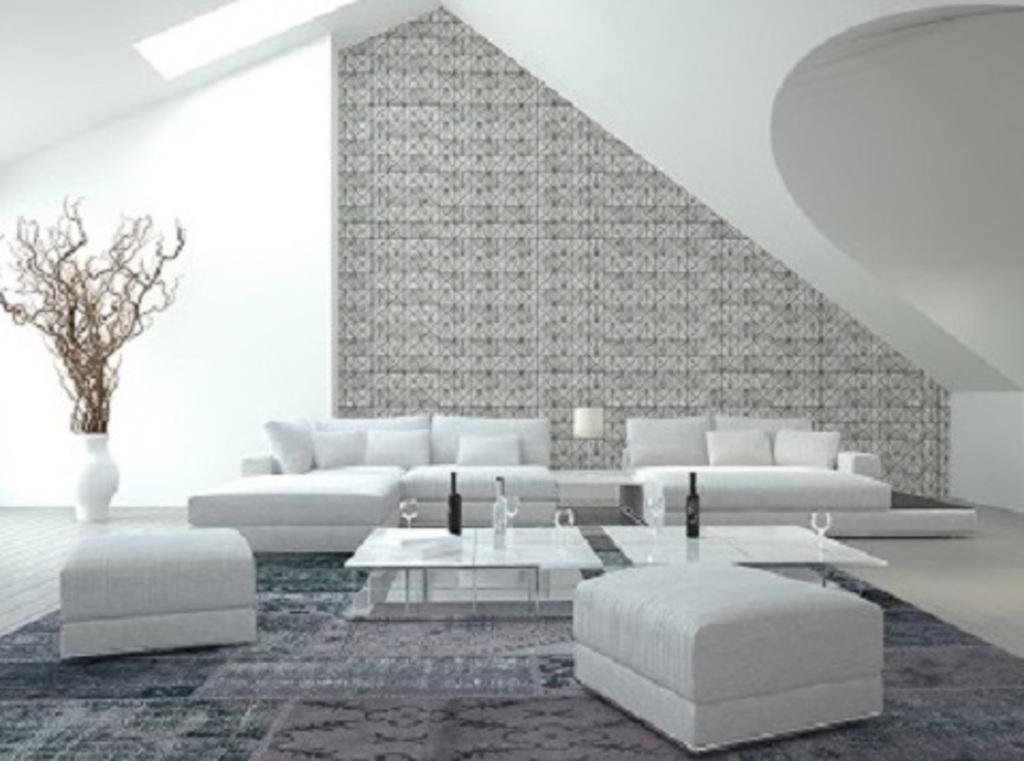Could you give a brief overview of what you see in this image? In this image I see a sofa set and 2 tables in front on which there are 3 bottles and 4 glasses. In the background I see the wall, a lamp and a plant in the pot. 